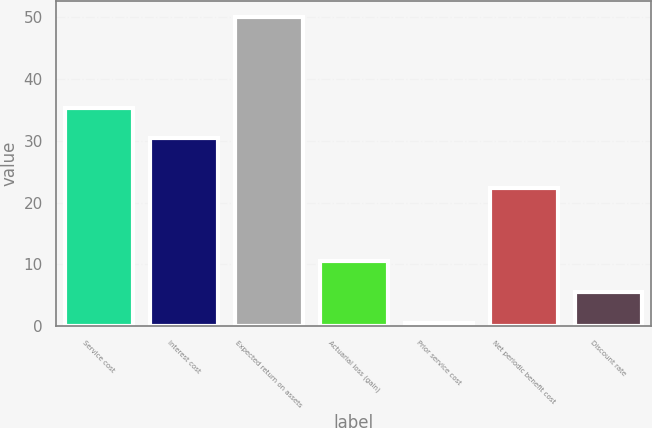<chart> <loc_0><loc_0><loc_500><loc_500><bar_chart><fcel>Service cost<fcel>Interest cost<fcel>Expected return on assets<fcel>Actuarial loss (gain)<fcel>Prior service cost<fcel>Net periodic benefit cost<fcel>Discount rate<nl><fcel>35.35<fcel>30.4<fcel>50.1<fcel>10.5<fcel>0.6<fcel>22.4<fcel>5.55<nl></chart> 